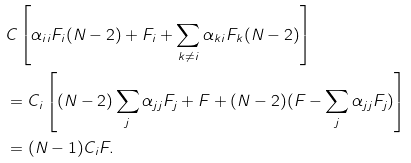<formula> <loc_0><loc_0><loc_500><loc_500>& C \left [ \alpha _ { i i } F _ { i } ( N - 2 ) + F _ { i } + \sum _ { k \neq i } \alpha _ { k i } F _ { k } ( N - 2 ) \right ] \\ & = C _ { i } \left [ ( N - 2 ) \sum _ { j } \alpha _ { j j } F _ { j } + F + ( N - 2 ) ( F - \sum _ { j } \alpha _ { j j } F _ { j } ) \right ] \\ & = ( N - 1 ) C _ { i } F .</formula> 